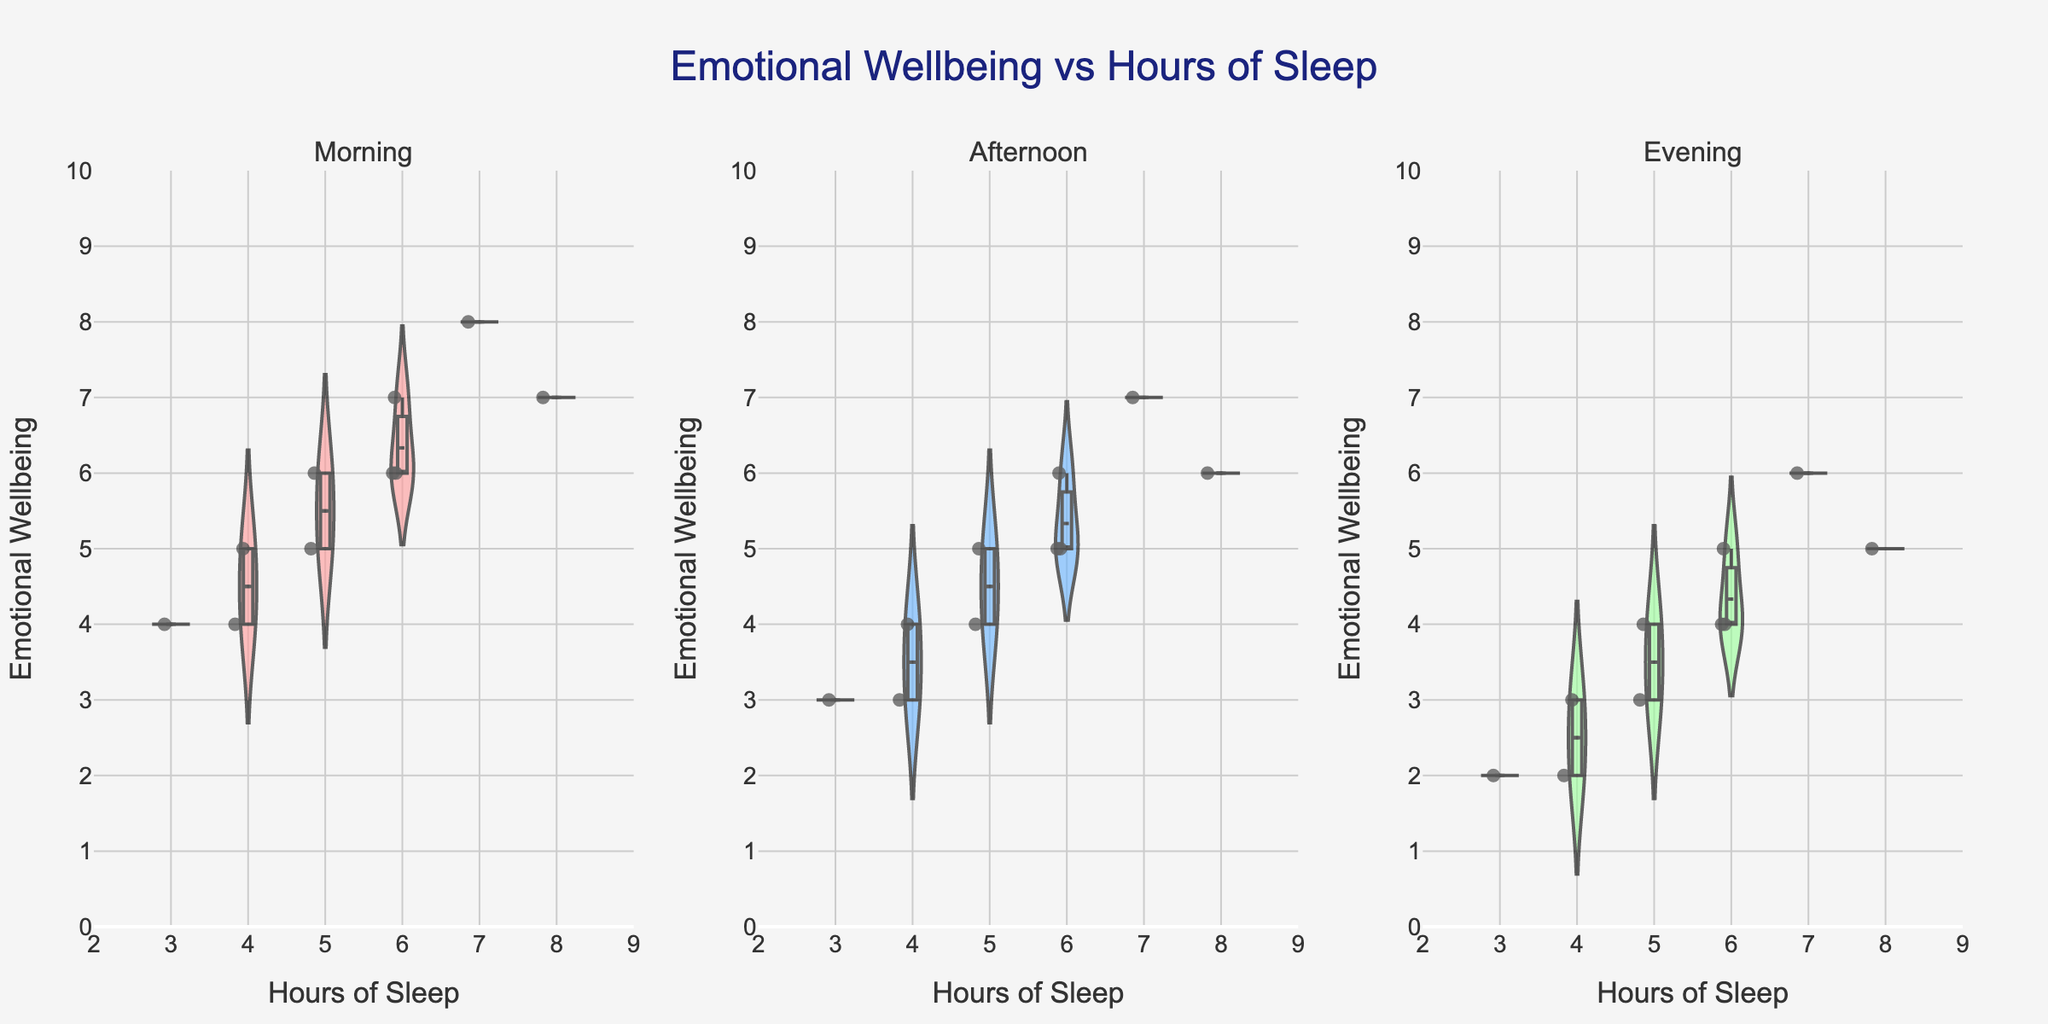What is the title of the figure? The title of the figure is located at the top center and provides an overview of what the data represents. Here, it states the relationship between emotional wellbeing and hours of sleep.
Answer: Emotional Wellbeing vs Hours of Sleep How many hours of sleep are on the x-axis? The x-axis range is shown with ticks from 2 to 9, suggesting 8 possible values for hours of sleep.
Answer: 8 What’s the mean emotional wellbeing rating for 6 hours of sleep in the Afternoon? By looking at the violin chart for the Afternoon, we can see the spread of ratings for 6 hours of sleep. Identify the mean line—this represents the average rating.
Answer: 5 Which time of day shows the highest variability in emotional wellbeing ratings for 4 hours of sleep? Identify the spread of the violins for each time of day focusing on 4 hours. The wider the spread, the higher the variability.
Answer: Evening Is the overall emotional wellbeing higher in the Morning or Evening for the same hours of sleep? Compare the heights of the violin charts for Morning and Evening across the same hours of sleep. Morning tends to have higher emotional wellbeing ratings across the range.
Answer: Morning What does the box in each violin represent? The box in each violin chart provides a visual representation of the interquartile range (IQR), which includes the middle 50% of the data.
Answer: Interquartile range (IQR) Which time of day has the most data points with 7 hours of sleep? Check the density of points for 7 hours of sleep in each violin plot. The Morning time-of-day chart indicates the highest density for 7 hours of sleep.
Answer: Morning 